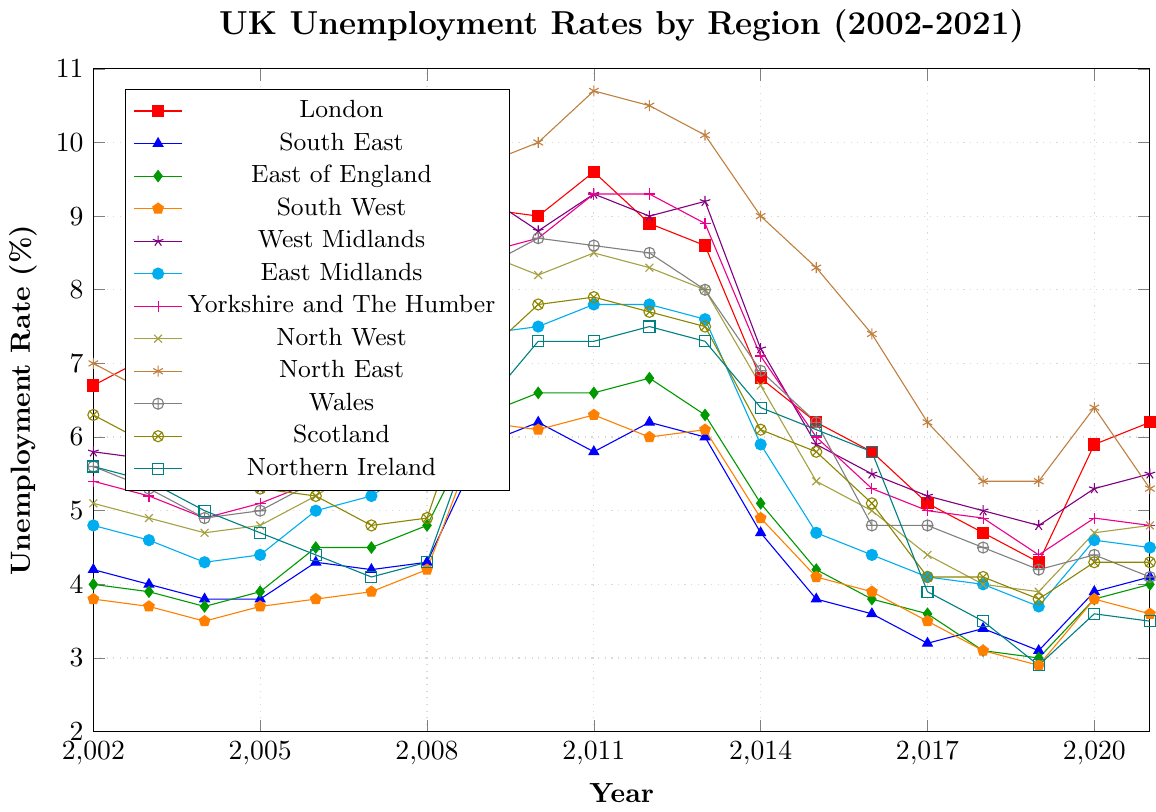Which region experienced the highest peak unemployment rate over the past two decades? The North East had the highest peak unemployment rate. By examining the peaks of each line in the figure, the North East shows the highest value of 10.7% in 2011.
Answer: North East Which year showed the largest increase in unemployment rate for London from the previous year? By examining the changes year to year on the London line, the largest increase was from 2008 to 2009, going from 6.9% to 9.1%, an increase of 2.2 percentage points.
Answer: 2009 In 2010, which region had a lower unemployment rate, Wales or Scotland? By comparing the points for Wales and Scotland in 2010, Wales had 8.7%, whereas Scotland had 7.8%. Therefore, Scotland had a lower unemployment rate in 2010.
Answer: Scotland How much did the unemployment rate in the South West decrease from 2013 to 2019? In 2013, the South West had an unemployment rate of 6.1%, and by 2019, it was 2.9%. The decrease is 6.1% - 2.9% = 3.2 percentage points.
Answer: 3.2% Which region had the smallest variation in unemployment rate over the entire period? The South East has the smoothest line and the smallest variation. By looking at the troughs and peaks, its range is from about 3.1% to 6.2%, which is smaller compared to other regions.
Answer: South East Compare the unemployment rates of the East Midlands and London in 2021. Which region had a lower rate? In 2021, the East Midlands had an unemployment rate of 4.5%, whereas London had an unemployment rate of 6.2%. Thus, the East Midlands had a lower rate.
Answer: East Midlands What was the average unemployment rate in Scotland over the period 2002 to 2021? To find the average, sum all the unemployment rates for Scotland between 2002 and 2021, then divide by the number of years. (6.3 + 5.9 + 5.5 + 5.3 + 5.2 + 4.8 + 4.9 + 7.1 + 7.8 + 7.9 + 7.7 + 7.5 + 6.1 + 5.8 + 5.1 + 4.1 + 4.1 + 3.8 + 4.3 + 4.3) / 20 = 5.67%
Answer: 5.67% Which region showed the most significant decline in unemployment rate between its peak and 2021? The North East had its peak at 10.7% in 2011 and dropped to 5.3% by 2021. The decline is 10.7% - 5.3% = 5.4 percentage points, which is the most significant decline when compared to other regions.
Answer: North East From 2008 to 2009, which region experienced the highest absolute increase in unemployment rate? By comparing the lines from 2008 to 2009, the North East experienced the highest increase, from 7.2% in 2008 to 9.7% in 2009, an absolute increase of 2.5 percentage points.
Answer: North East Which regions had similar unemployment rates in 2017? In 2017, the regions with similar unemployment rates include the East Midlands, Yorkshire and The Humber, and Wales, all around 4.0%, showing closely positioned values.
Answer: East Midlands, Yorkshire and The Humber, Wales 